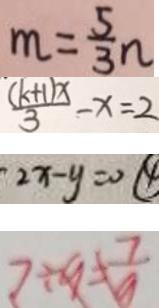<formula> <loc_0><loc_0><loc_500><loc_500>m = \frac { 5 } { 3 } n 
 \frac { ( k + 1 ) x } { 3 } - x = 2 
 2 x - y = 0 \textcircled { 4 } 
 7 \div 9 = \frac { 7 } { 9 }</formula> 